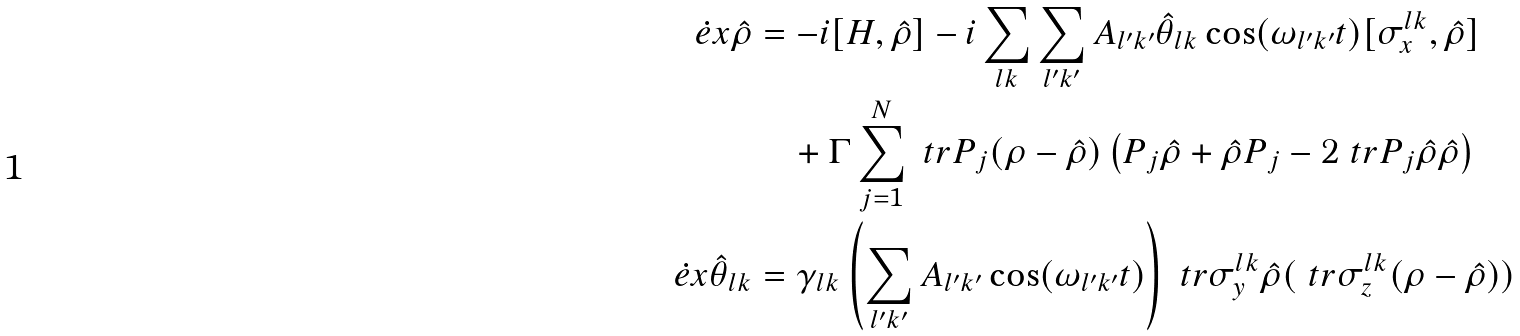Convert formula to latex. <formula><loc_0><loc_0><loc_500><loc_500>\dot { e } x \hat { \rho } & = - i [ H , \hat { \rho } ] - i \sum _ { l k } \sum _ { l ^ { \prime } k ^ { \prime } } A _ { l ^ { \prime } k ^ { \prime } } \hat { \theta } _ { l k } \cos ( \omega _ { l ^ { \prime } k ^ { \prime } } t ) [ \sigma _ { x } ^ { l k } , \hat { \rho } ] \\ & \quad + \Gamma \sum _ { j = 1 } ^ { N } \ t r { P _ { j } ( \rho - \hat { \rho } ) } \left ( P _ { j } \hat { \rho } + \hat { \rho } P _ { j } - 2 \ t r { P _ { j } \hat { \rho } } \hat { \rho } \right ) \\ \dot { e } x \hat { \theta } _ { l k } & = \gamma _ { l k } \left ( \sum _ { l ^ { \prime } k ^ { \prime } } A _ { l ^ { \prime } k ^ { \prime } } \cos ( \omega _ { l ^ { \prime } k ^ { \prime } } t ) \right ) \ t r { \sigma _ { y } ^ { l k } \hat { \rho } } ( \ t r { \sigma _ { z } ^ { l k } ( \rho - \hat { \rho } ) } )</formula> 